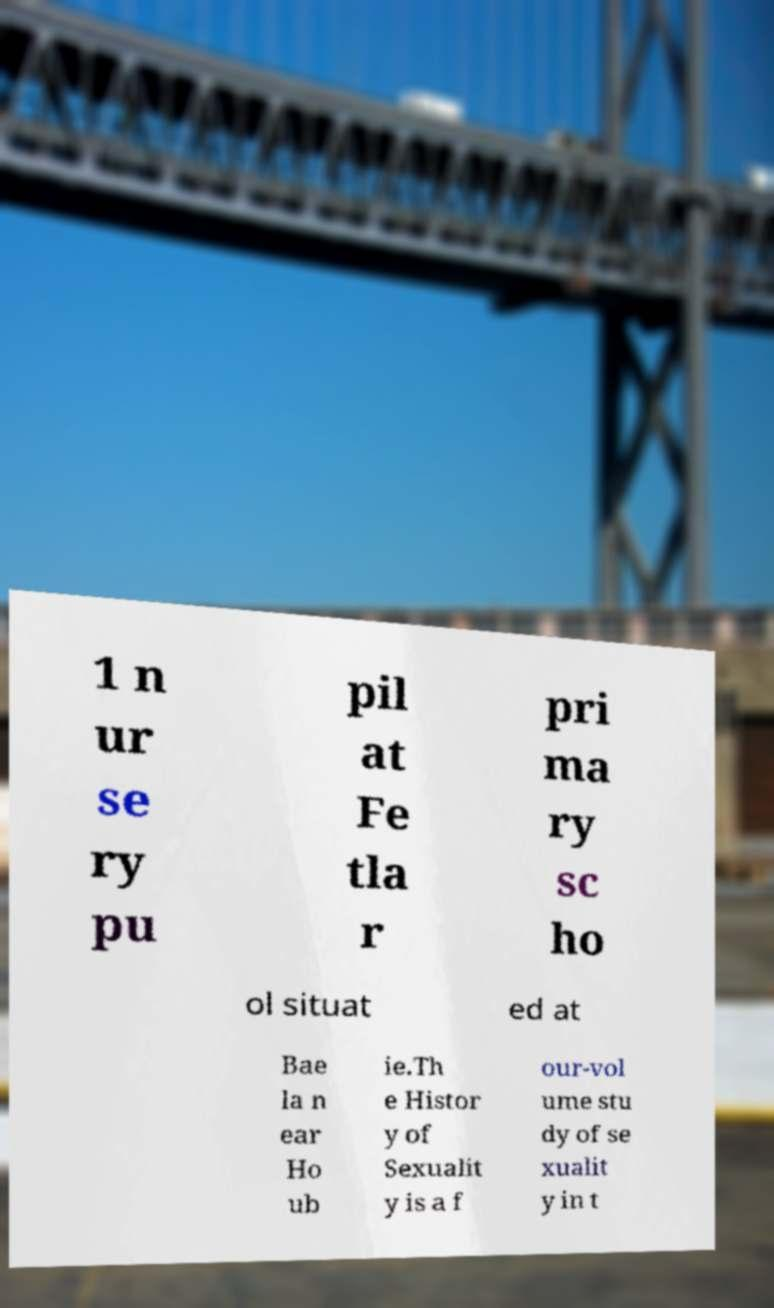What messages or text are displayed in this image? I need them in a readable, typed format. 1 n ur se ry pu pil at Fe tla r pri ma ry sc ho ol situat ed at Bae la n ear Ho ub ie.Th e Histor y of Sexualit y is a f our-vol ume stu dy of se xualit y in t 